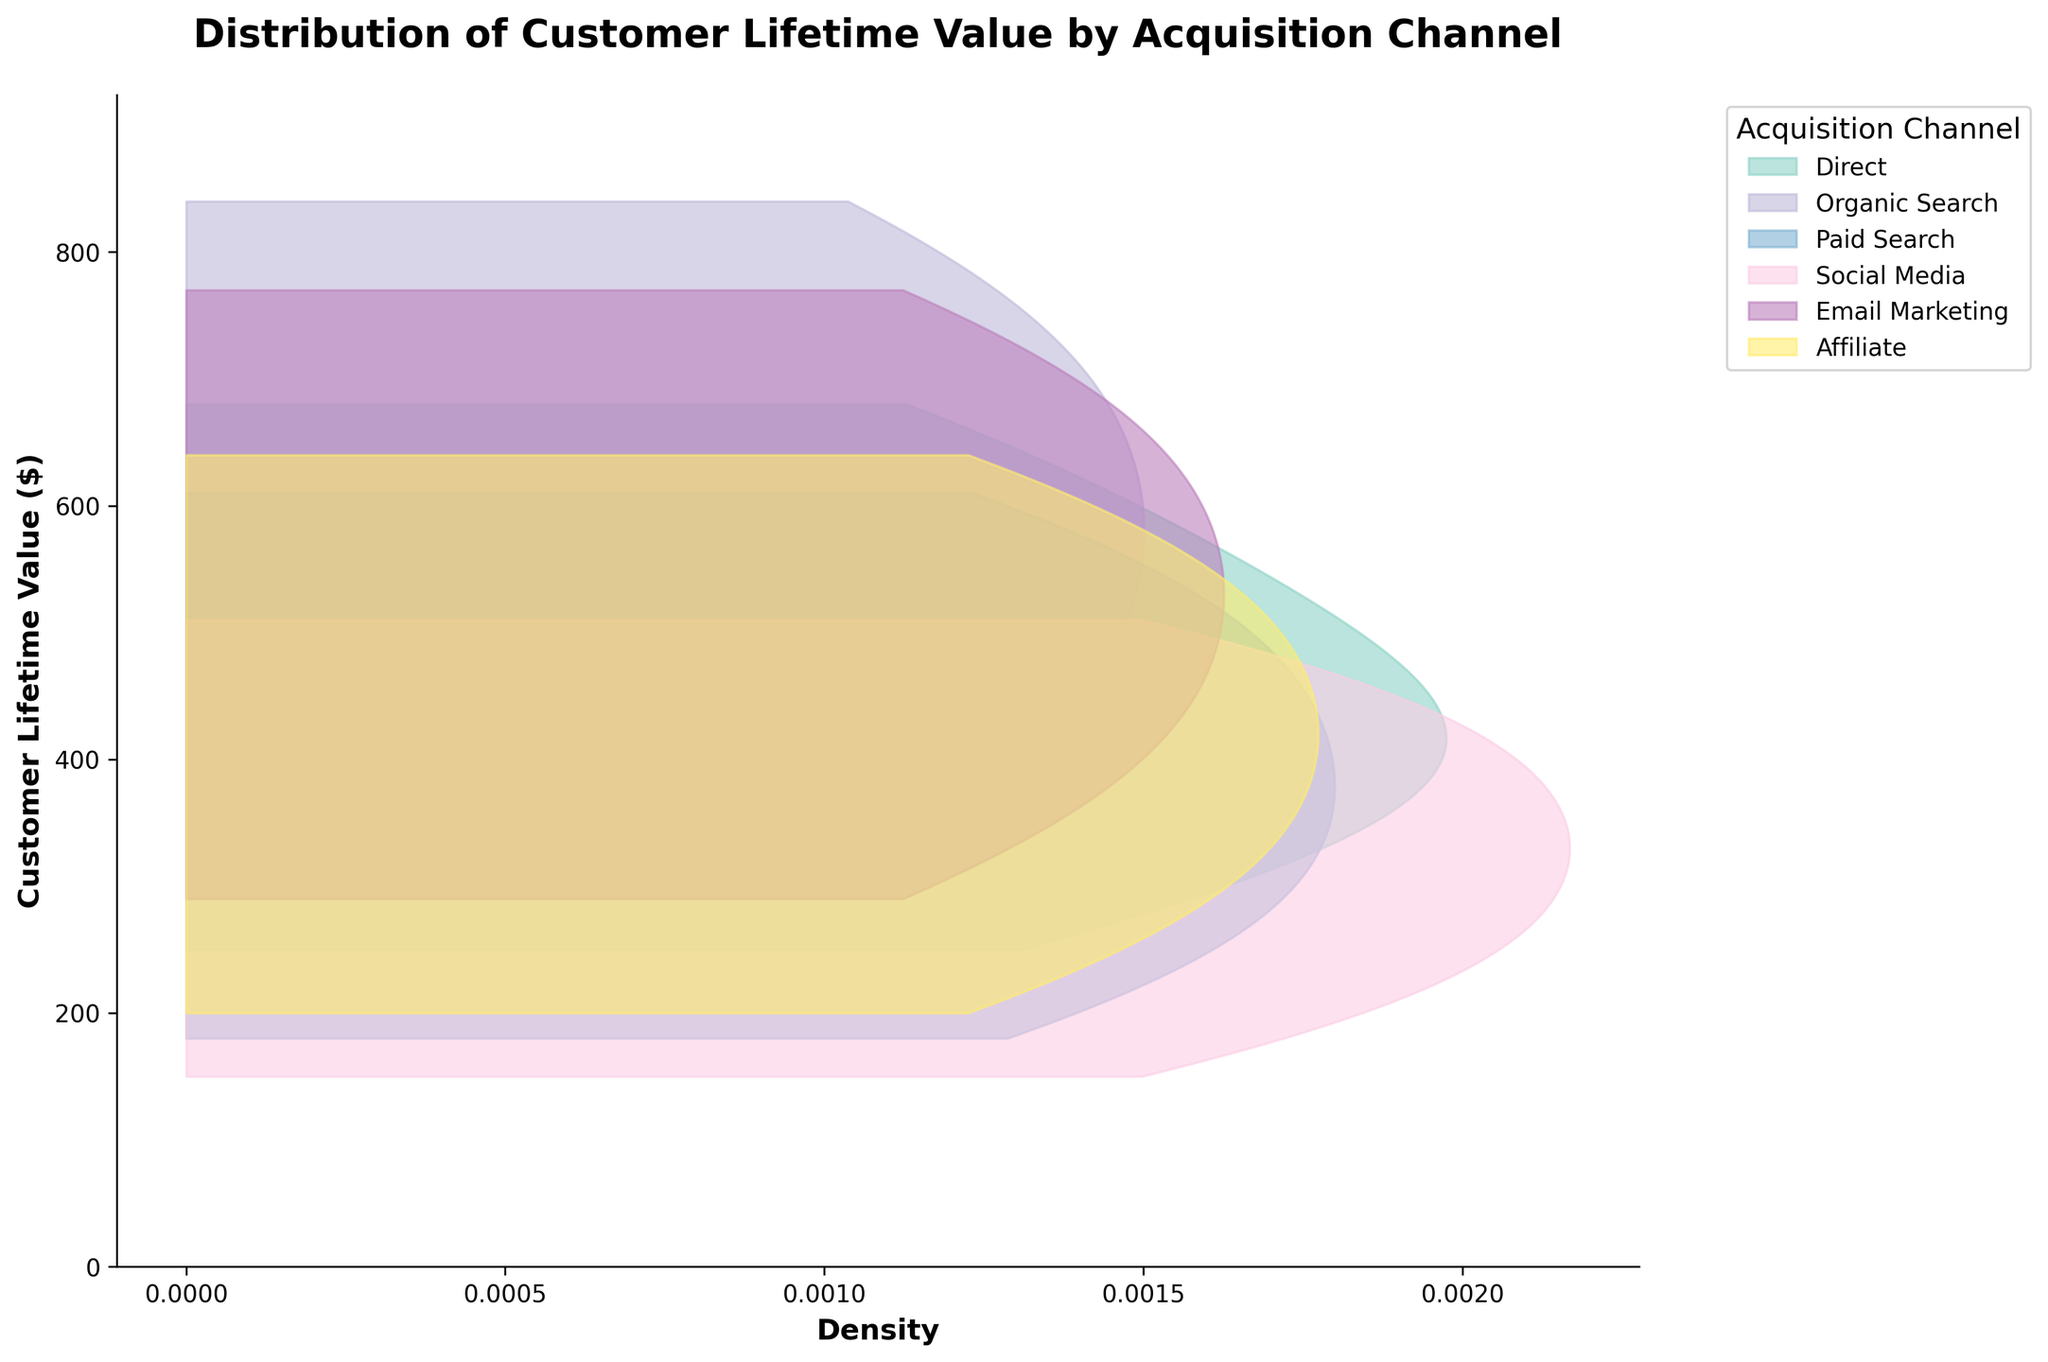What is the title of the plot? The title of the plot is written at the top of the figure. It summarizes what the plot is about. The title is "Distribution of Customer Lifetime Value by Acquisition Channel".
Answer: Distribution of Customer Lifetime Value by Acquisition Channel What is the color of the channel 'Email Marketing' in the plot? Each acquisition channel has a unique color in the plot. By referring to the legend box on the right side of the plot, 'Email Marketing' is represented by a specific color.
Answer: Light purple Which acquisition channel has the highest density peak in terms of Customer Lifetime Value? By looking at the density curves in the plot, we can identify the peaks and compare their heights. The channel with the highest peak represents the one with the highest density.
Answer: Organic Search What is the approximate range of LTV values for customers acquired through 'Paid Search'? To find the approximate range, observe where the density curve for 'Paid Search' starts and ends along the Y-axis, which represents LTV.
Answer: 180 to 610 Among all the channels, which one has the widest spread in Customer Lifetime Value? The spread is indicated by the range of values along the Y-axis covered by the density curves. The wider spread can be seen by comparing the horizontal extents of the curves.
Answer: Organic Search Which channel has a higher density for an LTV around 500, 'Direct' or 'Email Marketing'? Identify the LTV value of 500 on the Y-axis. Compare the density (width) of the 'Direct' and 'Email Marketing' density curves at this LTV value.
Answer: Email Marketing Do any acquisition channels have overlapping LTV density ranges? Look for overlapping regions in the horizontal density curves across different channels. If their density ranges (filled areas) overlap, those channels have overlapping LTV ranges.
Answer: Yes In terms of LTV distribution, which channel has more centralized values, and what does it indicate? A centralized distribution means the density curve is narrower and taller, suggesting most values are close to the mean. By observing the peaks and spread, we can identify the channel with centralized values.
Answer: Direct, indicates most customers have similar LTVs How does the density of 'Social Media' compare to 'Affiliate' at an LTV of 400? Look for the LTV value of 400 on the Y-axis and see the densities (width) of the 'Social Media' and 'Affiliate' curves at this point.
Answer: Social Media is lower than Affiliate Which acquisition channel shows a multimodal distribution of Customer Lifetime Value? A multimodal distribution will have multiple peaks in its density curve. By examining the shapes of the curves, identify which one shows more than one peak.
Answer: None 